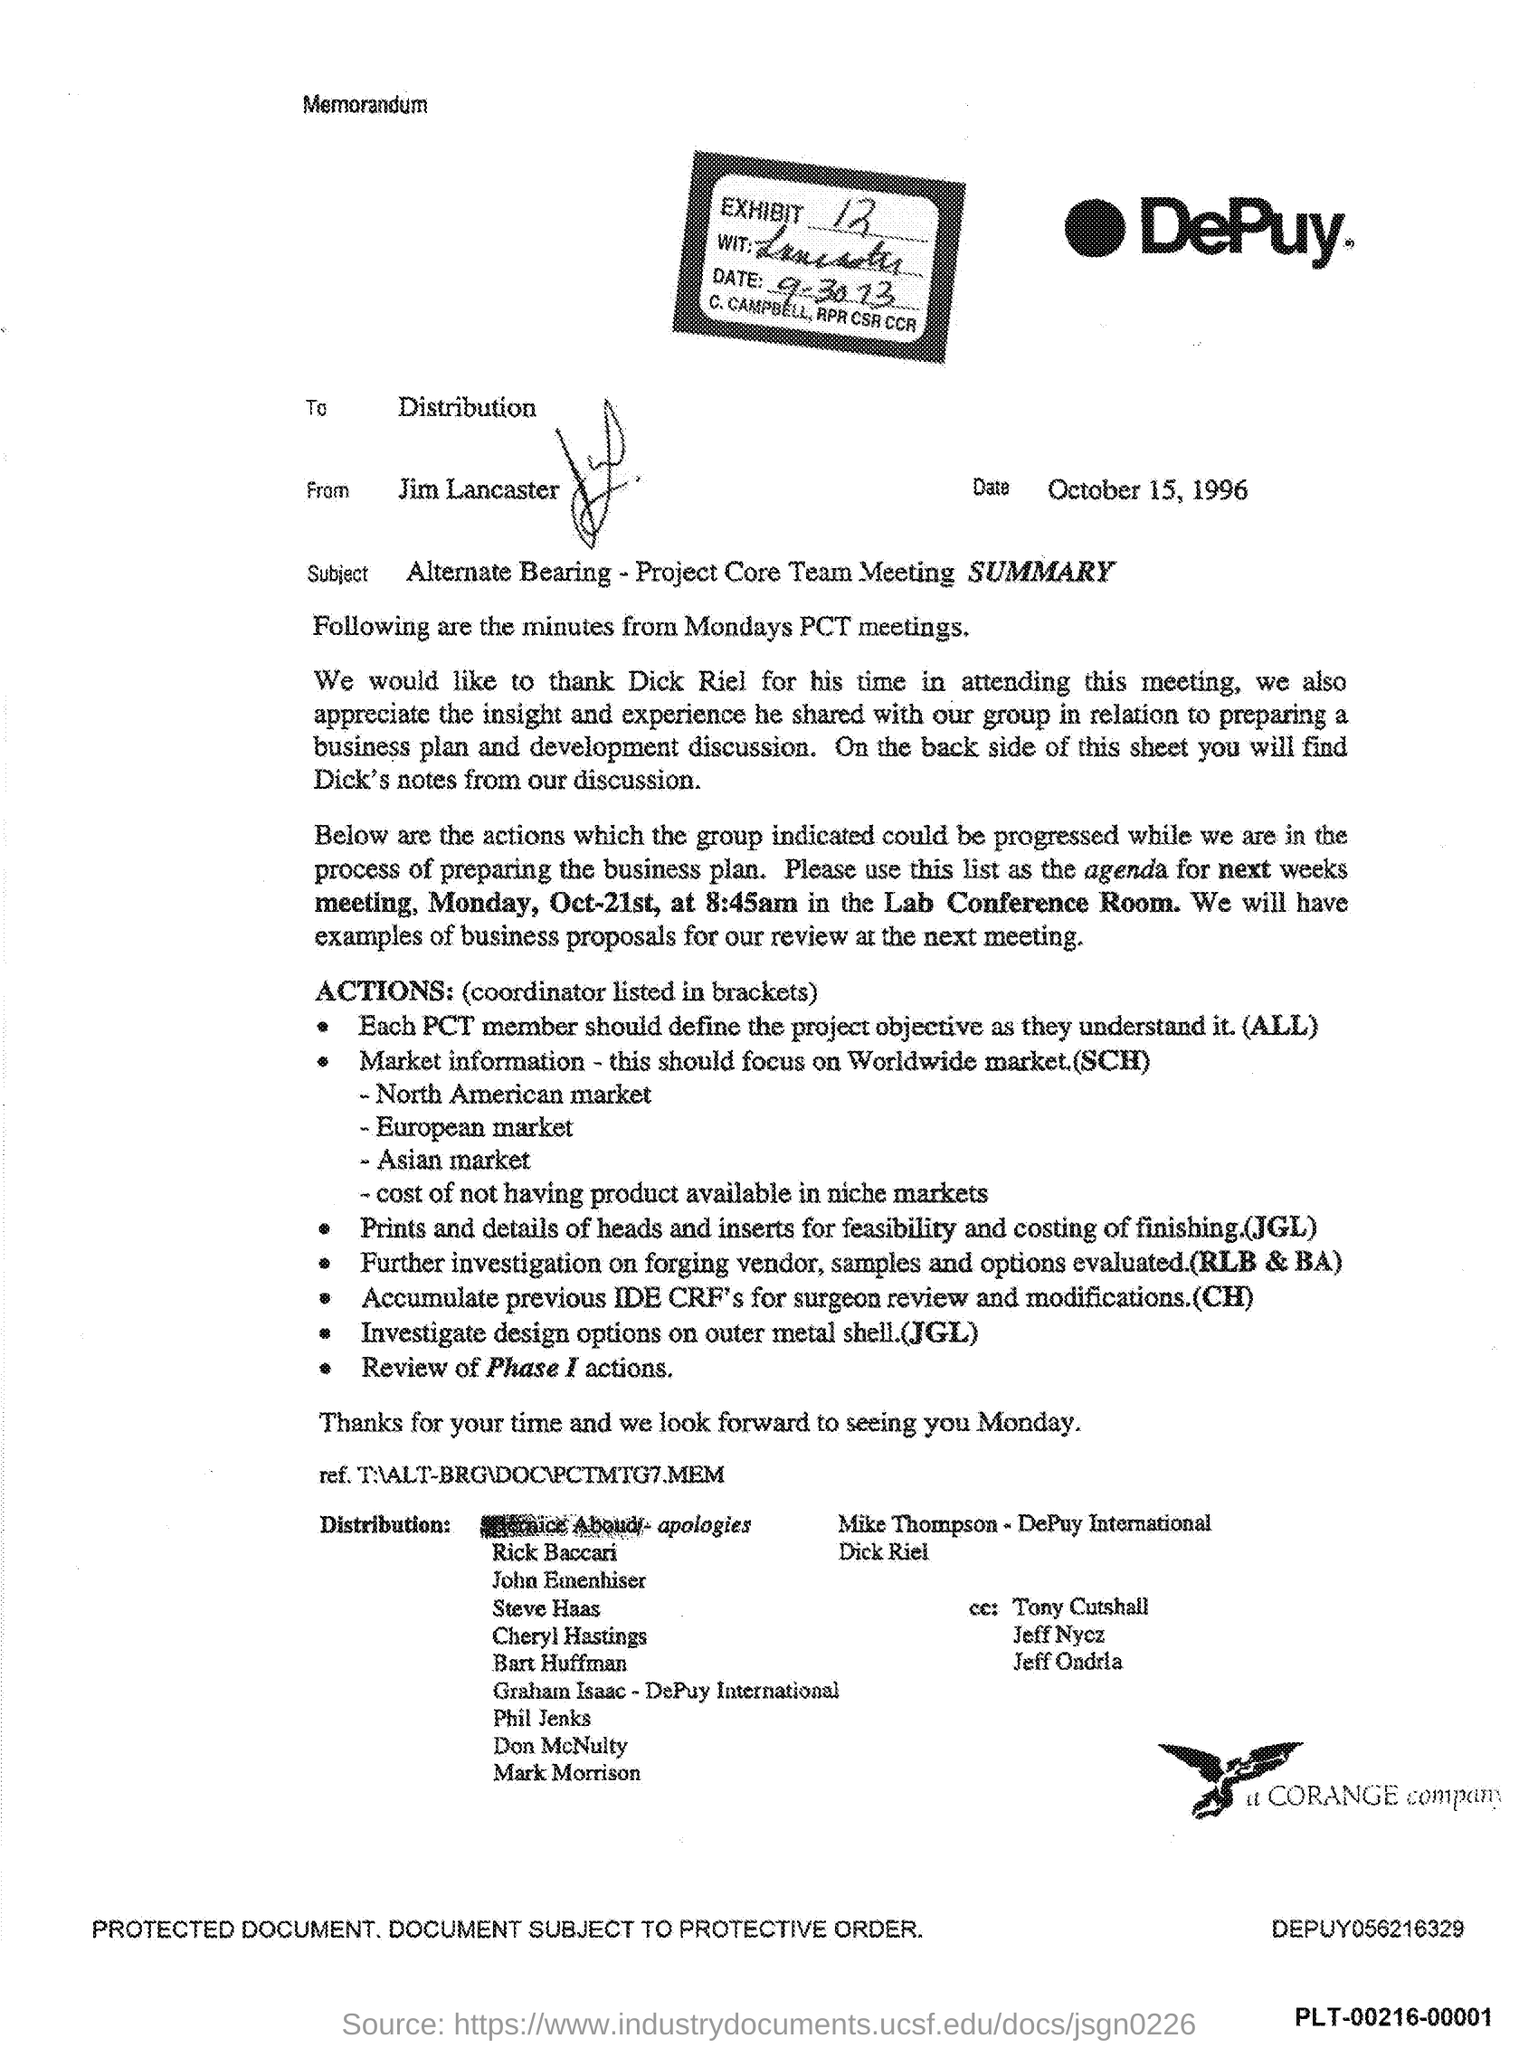What is the Exhibit No mentioned in the memorandum?
Provide a succinct answer. 12. Who is the sender of this memorandum?
Your answer should be compact. Jim Lancaster. What is the issued date of this memorandum?
Offer a very short reply. October 15, 1996. To whom, the memorandum is addressed?
Your answer should be compact. Distribution. What is the subject of this memorandum?
Offer a very short reply. Alternate Bearing - Project Core Team Meeting SUMMARY. Which company's memorandum is given here?
Your answer should be compact. DePuy. 